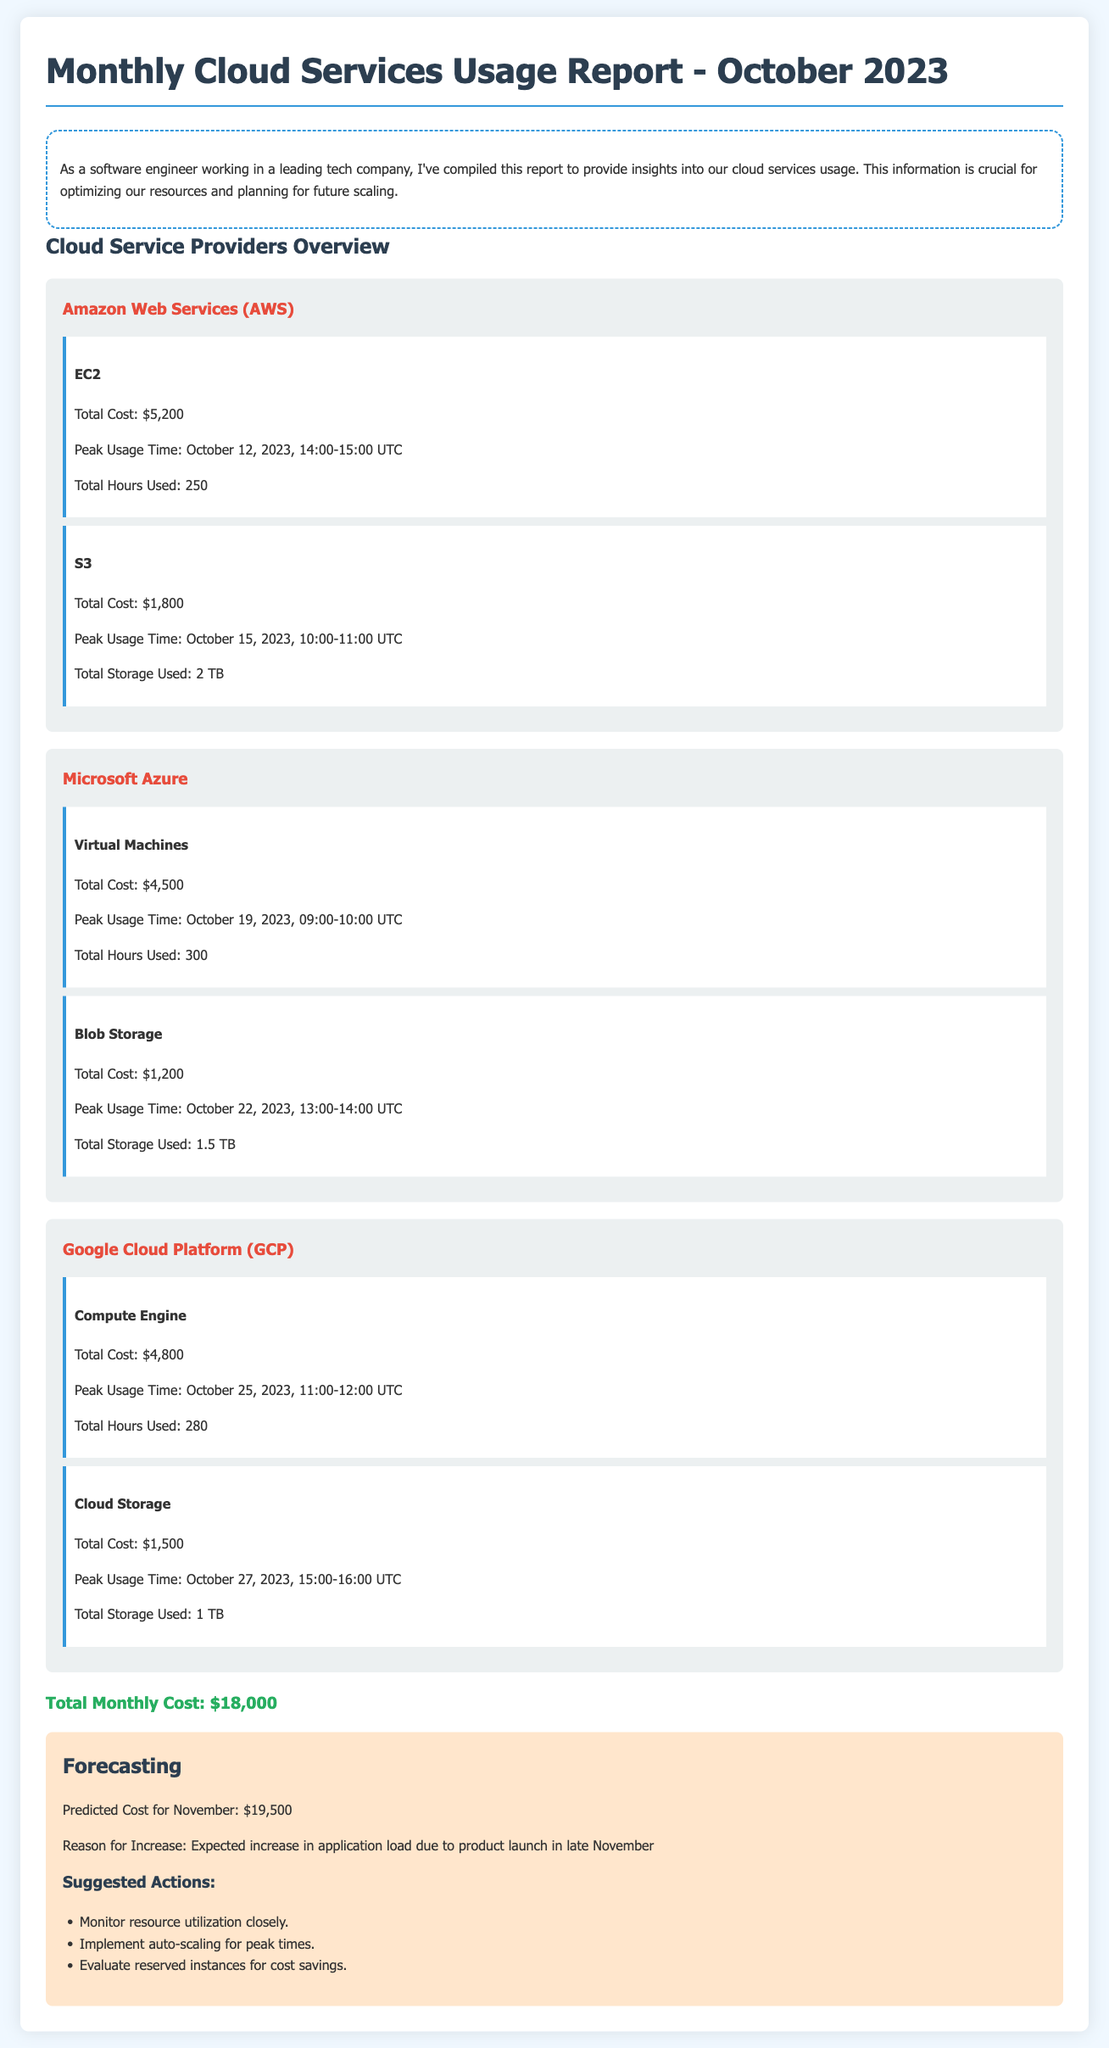What is the total cost for AWS services? The total cost for AWS services is the sum of the costs for EC2 and S3, which is $5,200 + $1,800 = $7,000.
Answer: $7,000 When is the peak usage time for Microsoft Azure Virtual Machines? The peak usage time for Microsoft Azure Virtual Machines is noted in the document, which is October 19, 2023, at 09:00-10:00 UTC.
Answer: October 19, 2023, 09:00-10:00 UTC What is the predicted cost for November? The predicted cost for November is specifically mentioned in the forecasting section.
Answer: $19,500 Which service had the highest total cost? The service with the highest total cost can be determined by comparing individual costs listed in the report.
Answer: EC2 What are the suggested actions in the forecasting section? The suggested actions include monitoring resource utilization, implementing auto-scaling during peak times, and evaluating reserved instances.
Answer: Monitor resource utilization, implement auto-scaling, evaluate reserved instances 